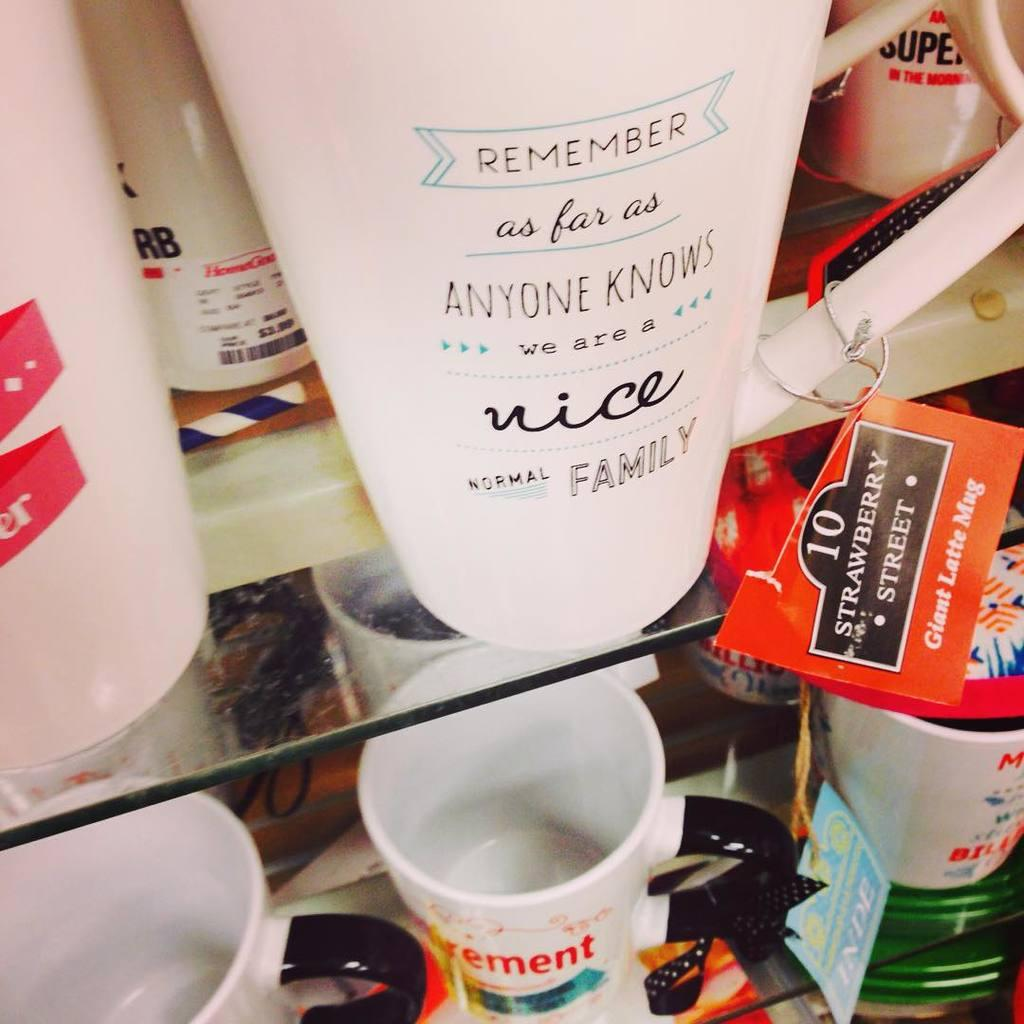<image>
Offer a succinct explanation of the picture presented. A white cup with the word nice on it among the other cups on the shelf 